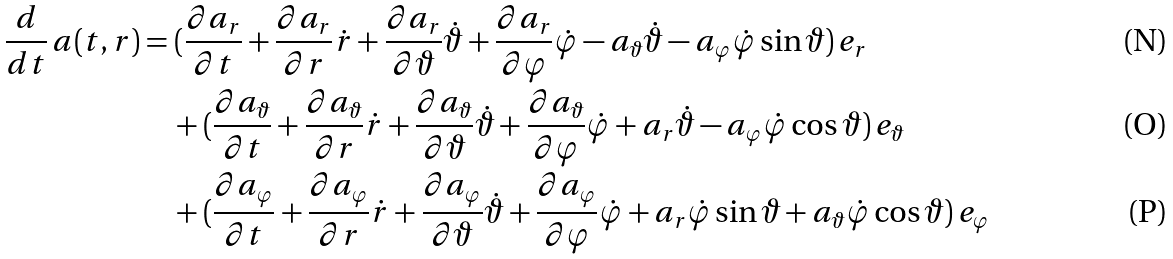<formula> <loc_0><loc_0><loc_500><loc_500>\frac { d } { d t } \, a ( t , r ) & = ( \frac { \partial a _ { r } } { \partial t } + \frac { \partial a _ { r } } { \partial r } \dot { r } + \frac { \partial a _ { r } } { \partial \vartheta } \dot { \vartheta } + \frac { \partial a _ { r } } { \partial \varphi } \dot { \varphi } - a _ { \vartheta } \dot { \vartheta } - a _ { \varphi } \dot { \varphi } \sin { \vartheta } ) \, e _ { r } \\ & \quad + ( \frac { \partial a _ { \vartheta } } { \partial t } + \frac { \partial a _ { \vartheta } } { \partial r } \dot { r } + \frac { \partial a _ { \vartheta } } { \partial \vartheta } \dot { \vartheta } + \frac { \partial a _ { \vartheta } } { \partial \varphi } \dot { \varphi } + a _ { r } \dot { \vartheta } - a _ { \varphi } \dot { \varphi } \cos { \vartheta } ) \, e _ { \vartheta } \\ & \quad + ( \frac { \partial a _ { \varphi } } { \partial t } + \frac { \partial a _ { \varphi } } { \partial r } \dot { r } + \frac { \partial a _ { \varphi } } { \partial \vartheta } \dot { \vartheta } + \frac { \partial a _ { \varphi } } { \partial \varphi } \dot { \varphi } + a _ { r } \dot { \varphi } \sin { \vartheta } + a _ { \vartheta } \dot { \varphi } \cos { \vartheta } ) \, e _ { \varphi }</formula> 